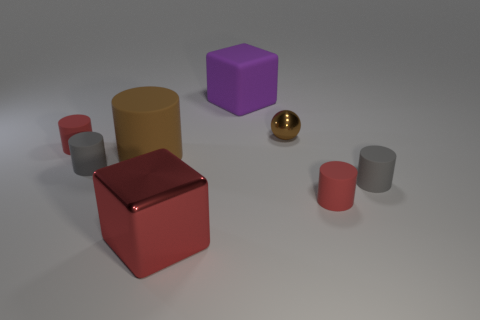Add 2 large purple things. How many objects exist? 10 Subtract all small cylinders. How many cylinders are left? 1 Subtract all red cylinders. How many cylinders are left? 3 Subtract 1 balls. How many balls are left? 0 Subtract all small brown spheres. Subtract all red cylinders. How many objects are left? 5 Add 1 large shiny blocks. How many large shiny blocks are left? 2 Add 7 rubber cubes. How many rubber cubes exist? 8 Subtract 0 blue balls. How many objects are left? 8 Subtract all spheres. How many objects are left? 7 Subtract all green cylinders. Subtract all brown blocks. How many cylinders are left? 5 